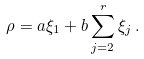Convert formula to latex. <formula><loc_0><loc_0><loc_500><loc_500>\rho = a \xi _ { 1 } + b \sum _ { j = 2 } ^ { r } \xi _ { j } \, .</formula> 